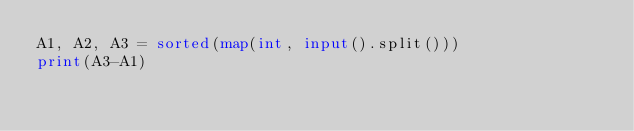<code> <loc_0><loc_0><loc_500><loc_500><_Python_>A1, A2, A3 = sorted(map(int, input().split()))
print(A3-A1)</code> 